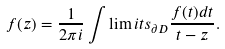Convert formula to latex. <formula><loc_0><loc_0><loc_500><loc_500>f ( z ) = \frac { 1 } { 2 \pi i } \int \lim i t s _ { \partial D } \frac { f ( t ) d t } { t - z } .</formula> 